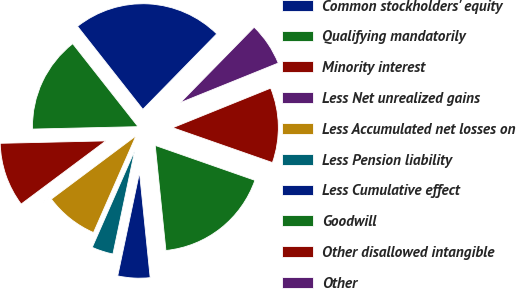<chart> <loc_0><loc_0><loc_500><loc_500><pie_chart><fcel>Common stockholders' equity<fcel>Qualifying mandatorily<fcel>Minority interest<fcel>Less Net unrealized gains<fcel>Less Accumulated net losses on<fcel>Less Pension liability<fcel>Less Cumulative effect<fcel>Goodwill<fcel>Other disallowed intangible<fcel>Other<nl><fcel>22.94%<fcel>14.75%<fcel>9.84%<fcel>0.01%<fcel>8.2%<fcel>3.28%<fcel>4.92%<fcel>18.03%<fcel>11.47%<fcel>6.56%<nl></chart> 